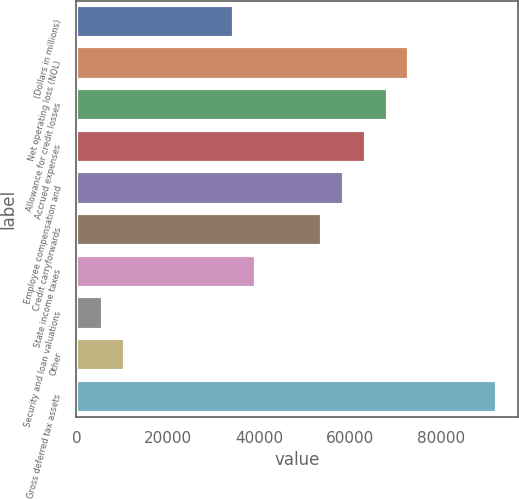Convert chart. <chart><loc_0><loc_0><loc_500><loc_500><bar_chart><fcel>(Dollars in millions)<fcel>Net operating loss (NOL)<fcel>Allowance for credit losses<fcel>Accrued expenses<fcel>Employee compensation and<fcel>Credit carryforwards<fcel>State income taxes<fcel>Security and loan valuations<fcel>Other<fcel>Gross deferred tax assets<nl><fcel>34616.3<fcel>72991.5<fcel>68194.6<fcel>63397.7<fcel>58600.8<fcel>53803.9<fcel>39413.2<fcel>5834.9<fcel>10631.8<fcel>92179.1<nl></chart> 